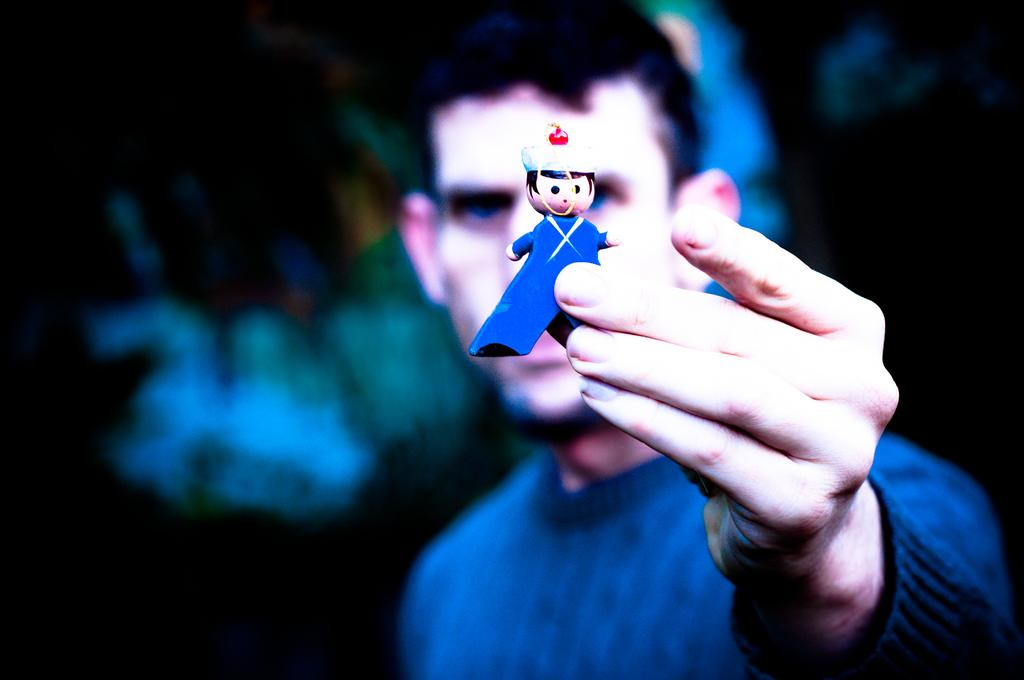What can be seen in the image? There is a person in the image. What is the person holding in his hand? The person is holding a toy in his hand. Can you describe the background of the image? The background of the image is blurred. How many tomatoes are on the roof in the image? There are no tomatoes or roof present in the image. 